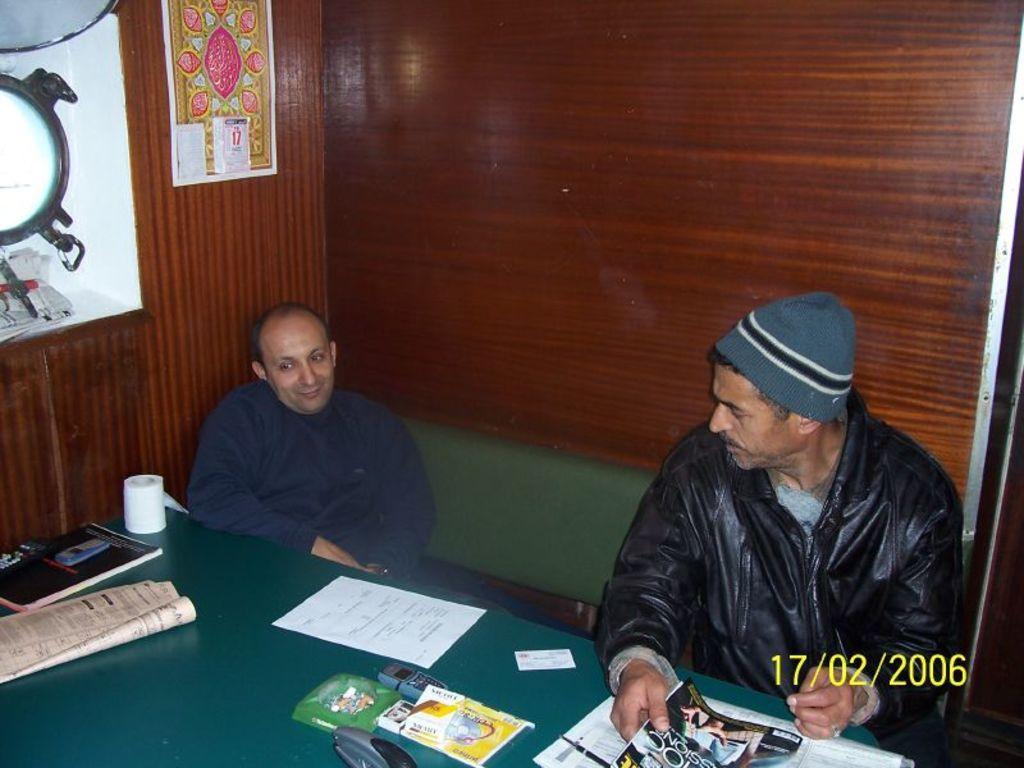Please provide a concise description of this image. In this picture there is a man who is wearing a blue shirt sitting on the chair and smiling. There is also another man who is wearing a black jacket and is holding a magazine in his hand. There is a tissue roll on the table. There is a paper and a book on the table. On the wall,there is a calendar. 